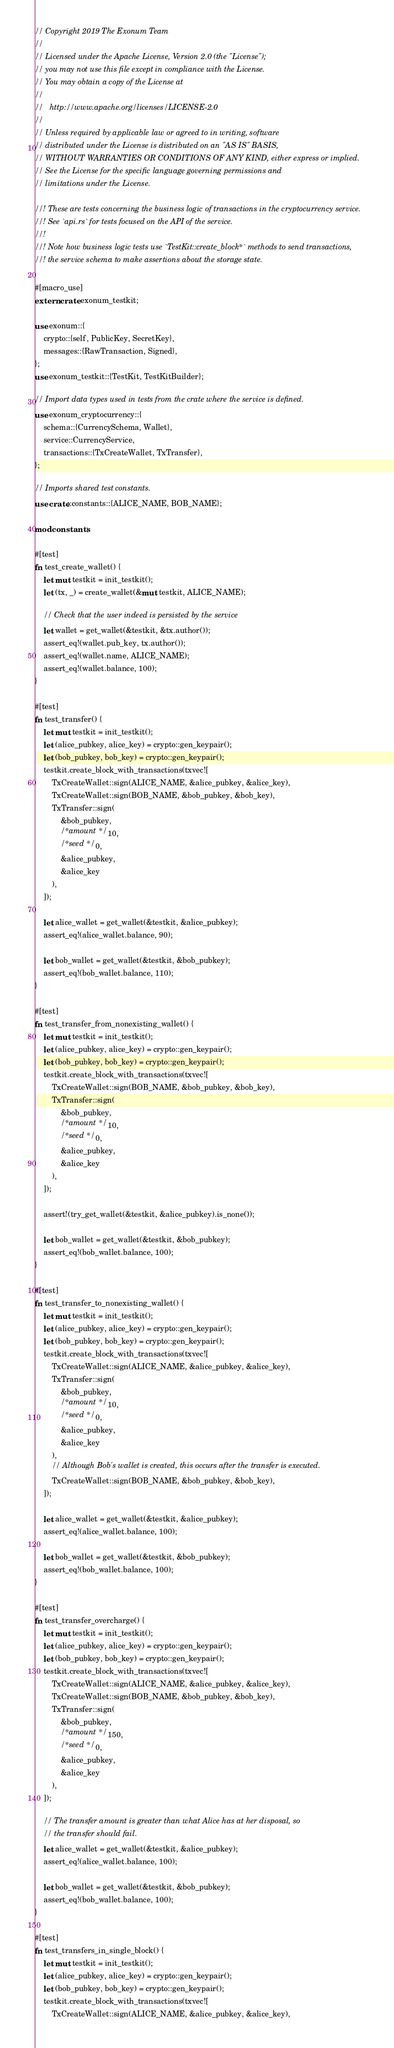Convert code to text. <code><loc_0><loc_0><loc_500><loc_500><_Rust_>// Copyright 2019 The Exonum Team
//
// Licensed under the Apache License, Version 2.0 (the "License");
// you may not use this file except in compliance with the License.
// You may obtain a copy of the License at
//
//   http://www.apache.org/licenses/LICENSE-2.0
//
// Unless required by applicable law or agreed to in writing, software
// distributed under the License is distributed on an "AS IS" BASIS,
// WITHOUT WARRANTIES OR CONDITIONS OF ANY KIND, either express or implied.
// See the License for the specific language governing permissions and
// limitations under the License.

//! These are tests concerning the business logic of transactions in the cryptocurrency service.
//! See `api.rs` for tests focused on the API of the service.
//!
//! Note how business logic tests use `TestKit::create_block*` methods to send transactions,
//! the service schema to make assertions about the storage state.

#[macro_use]
extern crate exonum_testkit;

use exonum::{
    crypto::{self, PublicKey, SecretKey},
    messages::{RawTransaction, Signed},
};
use exonum_testkit::{TestKit, TestKitBuilder};

// Import data types used in tests from the crate where the service is defined.
use exonum_cryptocurrency::{
    schema::{CurrencySchema, Wallet},
    service::CurrencyService,
    transactions::{TxCreateWallet, TxTransfer},
};

// Imports shared test constants.
use crate::constants::{ALICE_NAME, BOB_NAME};

mod constants;

#[test]
fn test_create_wallet() {
    let mut testkit = init_testkit();
    let (tx, _) = create_wallet(&mut testkit, ALICE_NAME);

    // Check that the user indeed is persisted by the service
    let wallet = get_wallet(&testkit, &tx.author());
    assert_eq!(wallet.pub_key, tx.author());
    assert_eq!(wallet.name, ALICE_NAME);
    assert_eq!(wallet.balance, 100);
}

#[test]
fn test_transfer() {
    let mut testkit = init_testkit();
    let (alice_pubkey, alice_key) = crypto::gen_keypair();
    let (bob_pubkey, bob_key) = crypto::gen_keypair();
    testkit.create_block_with_transactions(txvec![
        TxCreateWallet::sign(ALICE_NAME, &alice_pubkey, &alice_key),
        TxCreateWallet::sign(BOB_NAME, &bob_pubkey, &bob_key),
        TxTransfer::sign(
            &bob_pubkey,
            /* amount */ 10,
            /* seed */ 0,
            &alice_pubkey,
            &alice_key
        ),
    ]);

    let alice_wallet = get_wallet(&testkit, &alice_pubkey);
    assert_eq!(alice_wallet.balance, 90);

    let bob_wallet = get_wallet(&testkit, &bob_pubkey);
    assert_eq!(bob_wallet.balance, 110);
}

#[test]
fn test_transfer_from_nonexisting_wallet() {
    let mut testkit = init_testkit();
    let (alice_pubkey, alice_key) = crypto::gen_keypair();
    let (bob_pubkey, bob_key) = crypto::gen_keypair();
    testkit.create_block_with_transactions(txvec![
        TxCreateWallet::sign(BOB_NAME, &bob_pubkey, &bob_key),
        TxTransfer::sign(
            &bob_pubkey,
            /* amount */ 10,
            /* seed */ 0,
            &alice_pubkey,
            &alice_key
        ),
    ]);

    assert!(try_get_wallet(&testkit, &alice_pubkey).is_none());

    let bob_wallet = get_wallet(&testkit, &bob_pubkey);
    assert_eq!(bob_wallet.balance, 100);
}

#[test]
fn test_transfer_to_nonexisting_wallet() {
    let mut testkit = init_testkit();
    let (alice_pubkey, alice_key) = crypto::gen_keypair();
    let (bob_pubkey, bob_key) = crypto::gen_keypair();
    testkit.create_block_with_transactions(txvec![
        TxCreateWallet::sign(ALICE_NAME, &alice_pubkey, &alice_key),
        TxTransfer::sign(
            &bob_pubkey,
            /* amount */ 10,
            /* seed */ 0,
            &alice_pubkey,
            &alice_key
        ),
        // Although Bob's wallet is created, this occurs after the transfer is executed.
        TxCreateWallet::sign(BOB_NAME, &bob_pubkey, &bob_key),
    ]);

    let alice_wallet = get_wallet(&testkit, &alice_pubkey);
    assert_eq!(alice_wallet.balance, 100);

    let bob_wallet = get_wallet(&testkit, &bob_pubkey);
    assert_eq!(bob_wallet.balance, 100);
}

#[test]
fn test_transfer_overcharge() {
    let mut testkit = init_testkit();
    let (alice_pubkey, alice_key) = crypto::gen_keypair();
    let (bob_pubkey, bob_key) = crypto::gen_keypair();
    testkit.create_block_with_transactions(txvec![
        TxCreateWallet::sign(ALICE_NAME, &alice_pubkey, &alice_key),
        TxCreateWallet::sign(BOB_NAME, &bob_pubkey, &bob_key),
        TxTransfer::sign(
            &bob_pubkey,
            /* amount */ 150,
            /* seed */ 0,
            &alice_pubkey,
            &alice_key
        ),
    ]);

    // The transfer amount is greater than what Alice has at her disposal, so
    // the transfer should fail.
    let alice_wallet = get_wallet(&testkit, &alice_pubkey);
    assert_eq!(alice_wallet.balance, 100);

    let bob_wallet = get_wallet(&testkit, &bob_pubkey);
    assert_eq!(bob_wallet.balance, 100);
}

#[test]
fn test_transfers_in_single_block() {
    let mut testkit = init_testkit();
    let (alice_pubkey, alice_key) = crypto::gen_keypair();
    let (bob_pubkey, bob_key) = crypto::gen_keypair();
    testkit.create_block_with_transactions(txvec![
        TxCreateWallet::sign(ALICE_NAME, &alice_pubkey, &alice_key),</code> 